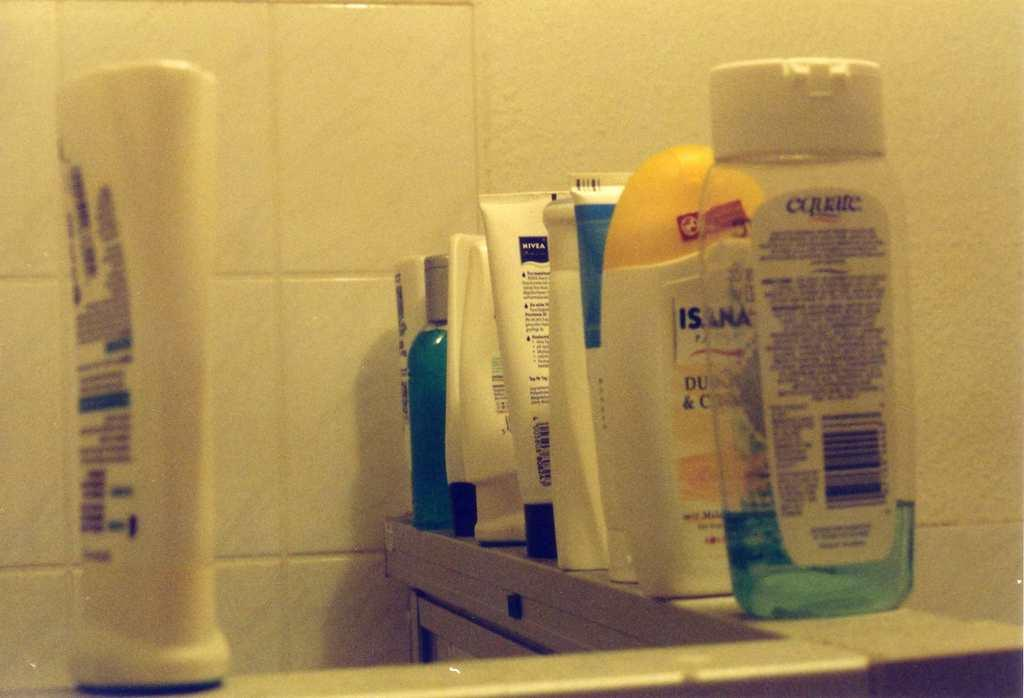Provide a one-sentence caption for the provided image. A bottle of equate shampoo sits with several other shampoos on a shower ledge. 